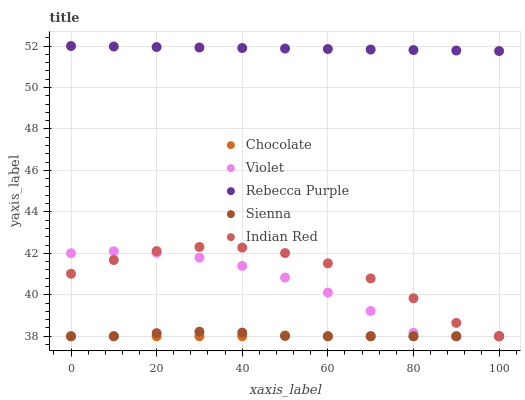Does Chocolate have the minimum area under the curve?
Answer yes or no. Yes. Does Rebecca Purple have the maximum area under the curve?
Answer yes or no. Yes. Does Violet have the minimum area under the curve?
Answer yes or no. No. Does Violet have the maximum area under the curve?
Answer yes or no. No. Is Rebecca Purple the smoothest?
Answer yes or no. Yes. Is Indian Red the roughest?
Answer yes or no. Yes. Is Violet the smoothest?
Answer yes or no. No. Is Violet the roughest?
Answer yes or no. No. Does Sienna have the lowest value?
Answer yes or no. Yes. Does Rebecca Purple have the lowest value?
Answer yes or no. No. Does Rebecca Purple have the highest value?
Answer yes or no. Yes. Does Violet have the highest value?
Answer yes or no. No. Is Chocolate less than Rebecca Purple?
Answer yes or no. Yes. Is Rebecca Purple greater than Sienna?
Answer yes or no. Yes. Does Violet intersect Sienna?
Answer yes or no. Yes. Is Violet less than Sienna?
Answer yes or no. No. Is Violet greater than Sienna?
Answer yes or no. No. Does Chocolate intersect Rebecca Purple?
Answer yes or no. No. 